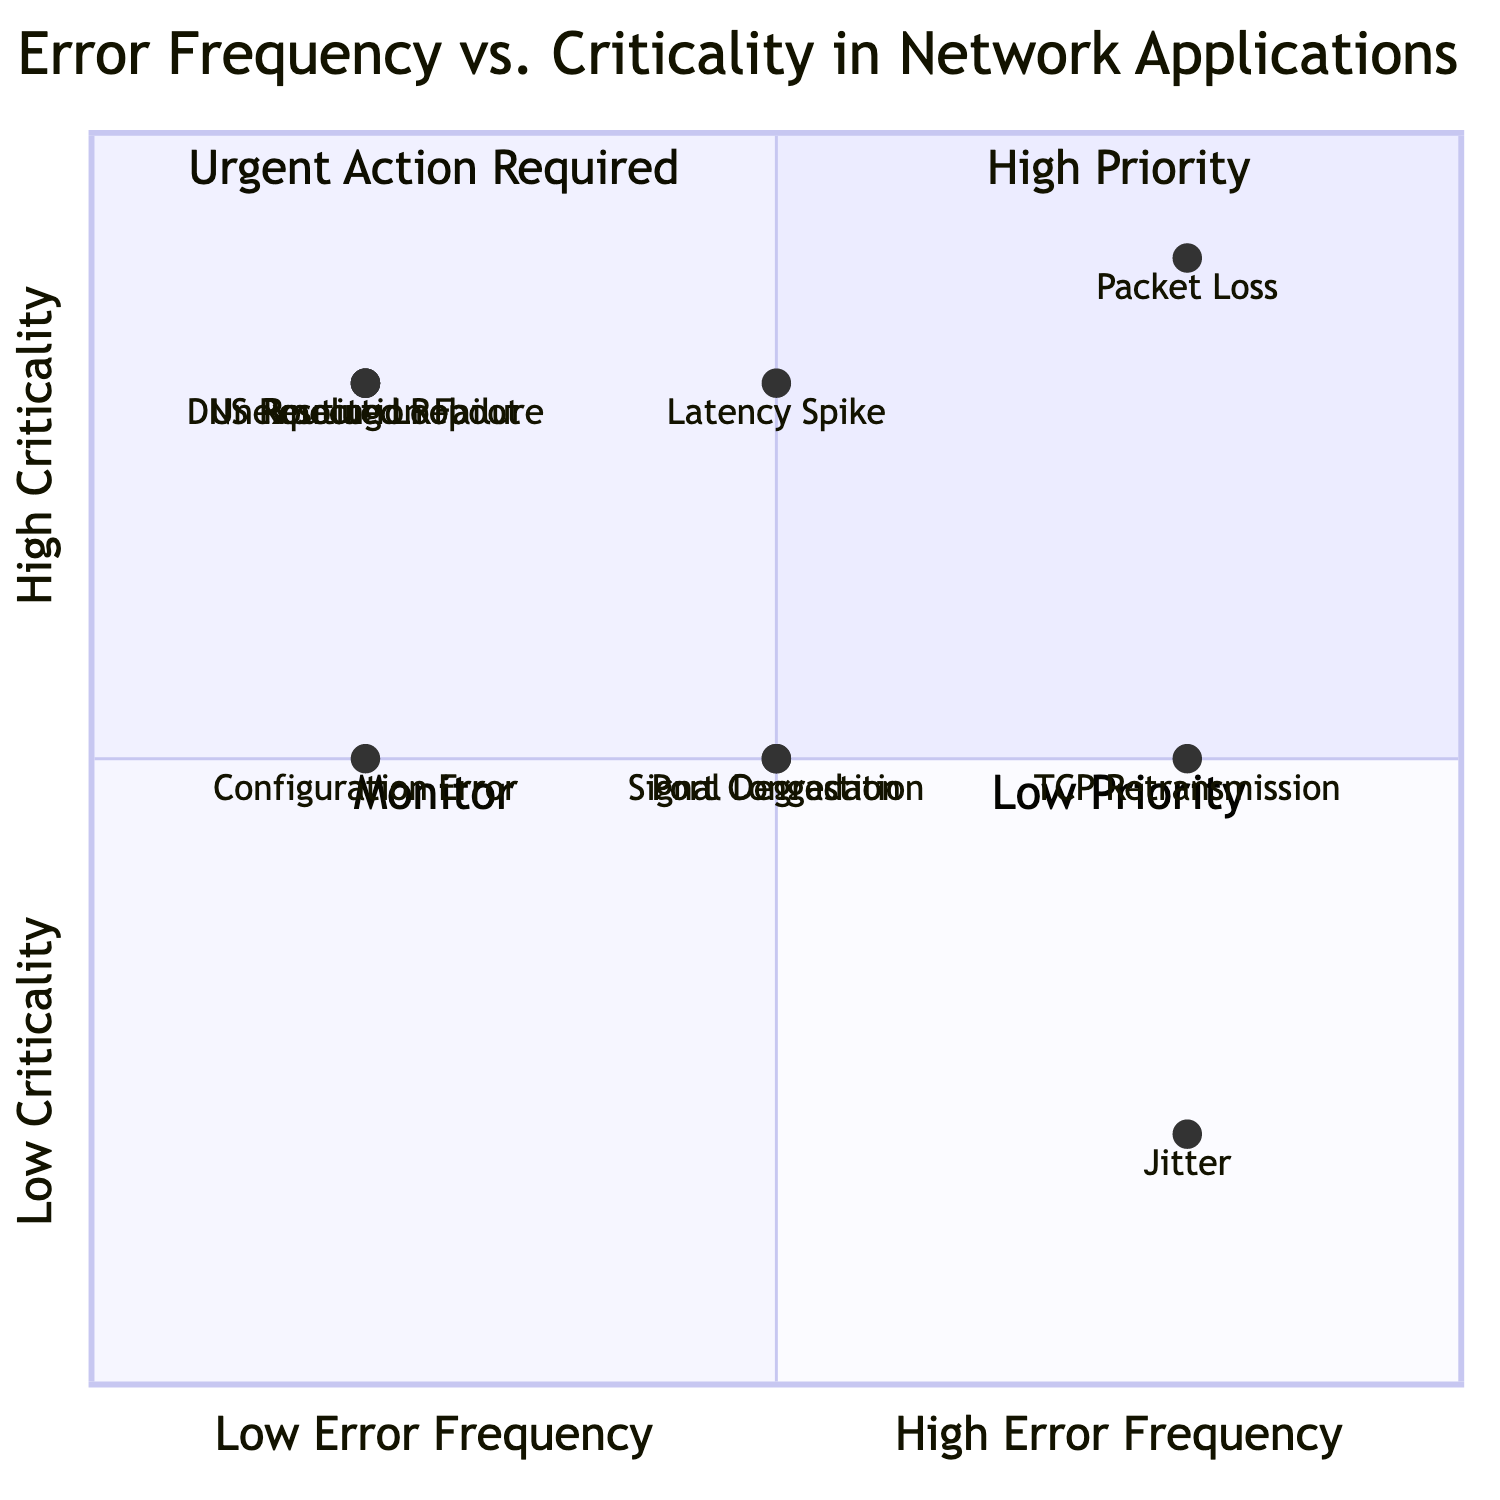What is the element with the highest frequency and criticality? The diagram shows that "Packet Loss" is located in the High Frequency and High Criticality quadrant. Therefore, it has both the highest error frequency and the highest criticality among all elements.
Answer: Packet Loss How many elements fall into the "Urgent Action Required" quadrant? In the diagram, elements with high criticality and high frequency fall into this quadrant. Only "Packet Loss" is in this area, leading to a count of one element.
Answer: 1 Which element has a low error frequency but high criticality? By examining the diagram, the elements in the High Criticality quadrant with low error frequency include "DNS Resolution Failure," "Unexpected Reboot," and "Routing Loop." All these elements meet the criteria.
Answer: DNS Resolution Failure, Unexpected Reboot, Routing Loop Which element shows high frequency but low criticality? "Jitter" is positioned in the diagram in such a way that it is categorized under high frequency and low criticality, as it is in the Low Criticality quadrant and far along the High Frequency axis.
Answer: Jitter What is the criticality level of "TCP Retransmission"? To find the criticality, we check the vertical position of "TCP Retransmission" in the diagram. It is positioned in the Medium Criticality range.
Answer: Medium Are there any elements that are categorized as "Low Priority"? Looking at the diagram, we note that the "Low Priority" quadrant contains only "Jitter" because it presents with high frequency but low criticality.
Answer: Yes, Jitter How many elements have low criticality? A total of two elements (Jitter and TCP Retransmission) are positioned at the Low Criticality level in the diagram.
Answer: 2 Which element has medium error frequency and medium criticality? By evaluating the positioning of elements, "Port Congestion" and "Signal Degradation" sit correctly in the Medium Criticality and Medium Frequency section, so both fit the criteria.
Answer: Port Congestion, Signal Degradation 